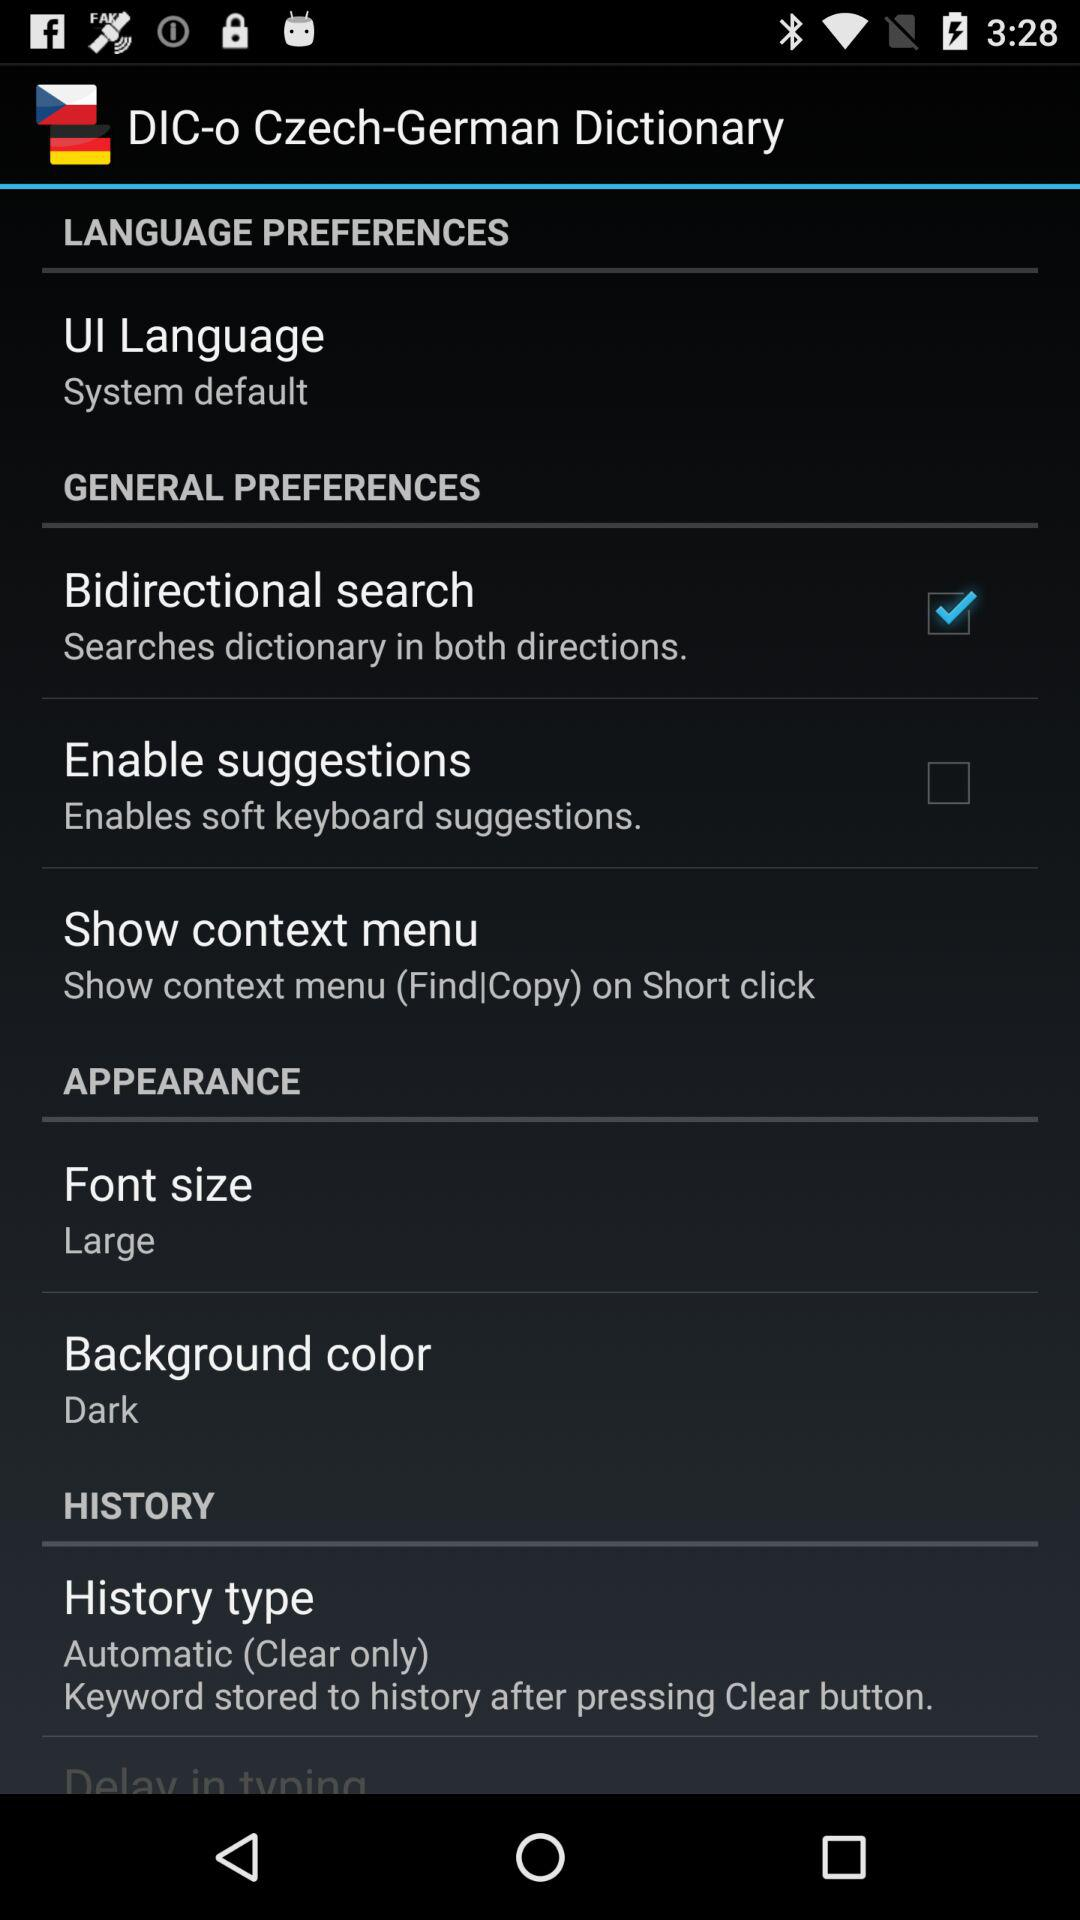Which option has been selected? The selected option is "Bidirectional search". 